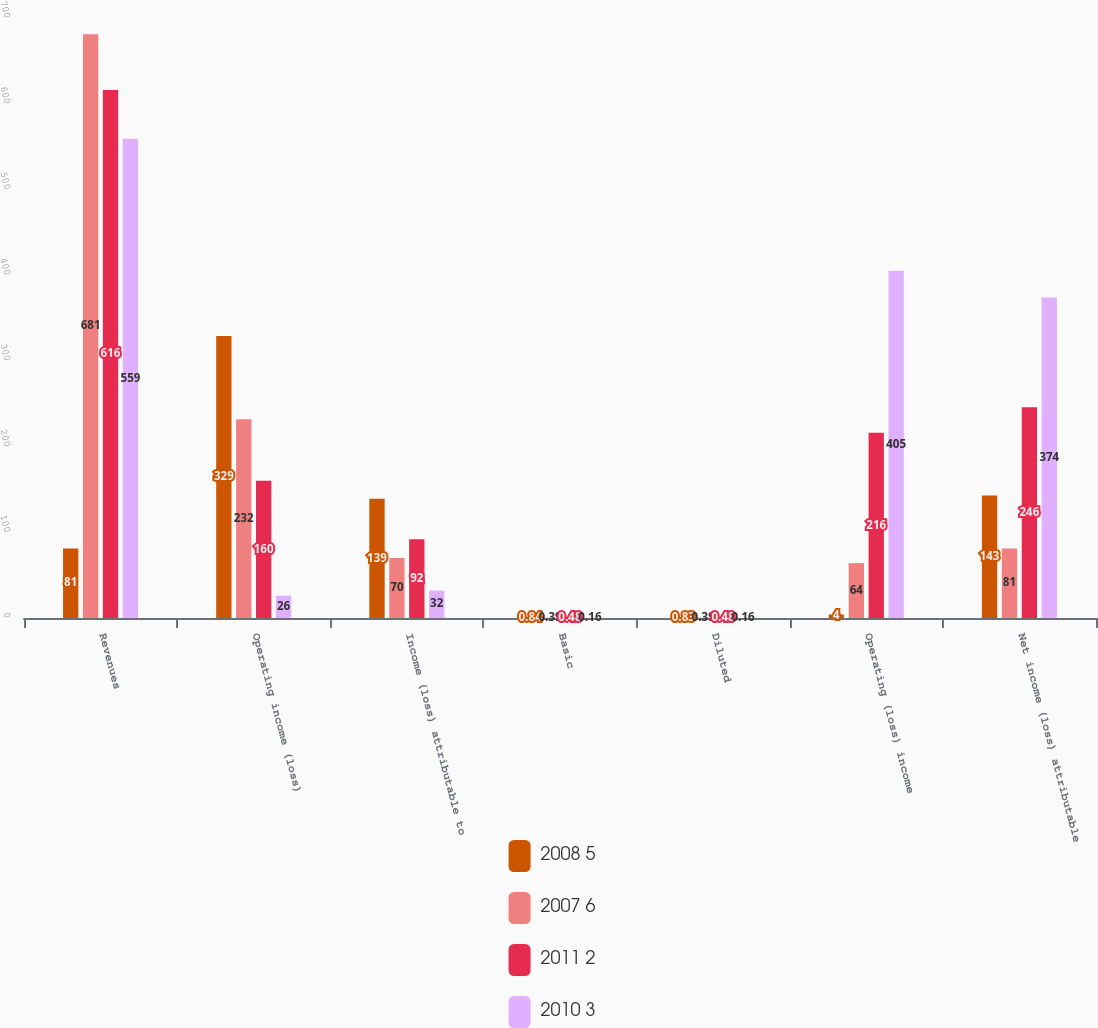<chart> <loc_0><loc_0><loc_500><loc_500><stacked_bar_chart><ecel><fcel>Revenues<fcel>Operating income (loss)<fcel>Income (loss) attributable to<fcel>Basic<fcel>Diluted<fcel>Operating (loss) income<fcel>Net income (loss) attributable<nl><fcel>2008 5<fcel>81<fcel>329<fcel>139<fcel>0.84<fcel>0.83<fcel>4<fcel>143<nl><fcel>2007 6<fcel>681<fcel>232<fcel>70<fcel>0.39<fcel>0.39<fcel>64<fcel>81<nl><fcel>2011 2<fcel>616<fcel>160<fcel>92<fcel>0.48<fcel>0.48<fcel>216<fcel>246<nl><fcel>2010 3<fcel>559<fcel>26<fcel>32<fcel>0.16<fcel>0.16<fcel>405<fcel>374<nl></chart> 